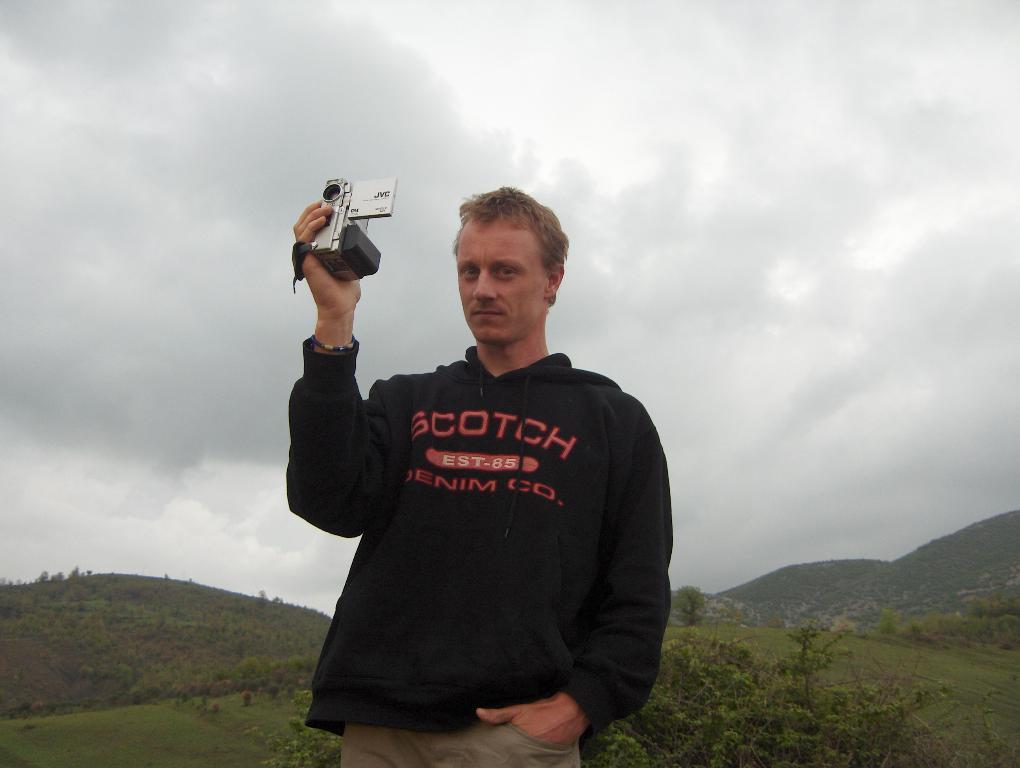Can you describe this image briefly? In this image, in the middle, we can see a man wearing a black color shirt and holding a camera in his hand. In the background, we can see some trees, plants, rocks. At the top, we can see a sky which is cloudy, at the bottom, we can see some trees, plants and a grass. 